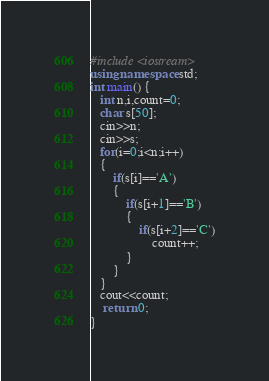<code> <loc_0><loc_0><loc_500><loc_500><_C++_>#include <iostream>
using namespace std;
int main() {
   int n,i,count=0;
   char s[50];
   cin>>n;
   cin>>s;
   for(i=0;i<n;i++)
   {
       if(s[i]=='A')
       {
           if(s[i+1]=='B')
           {
               if(s[i+2]=='C')
                   count++;
           }
       }
   }
   cout<<count;
    return 0;
}</code> 